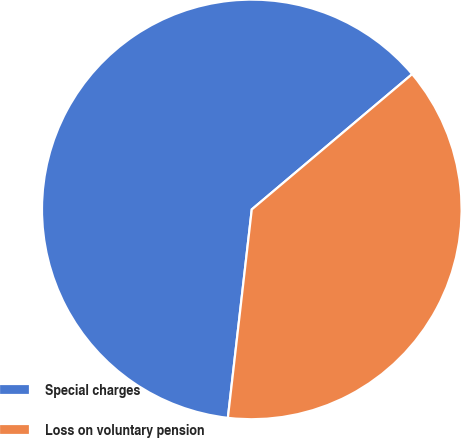<chart> <loc_0><loc_0><loc_500><loc_500><pie_chart><fcel>Special charges<fcel>Loss on voluntary pension<nl><fcel>62.03%<fcel>37.97%<nl></chart> 